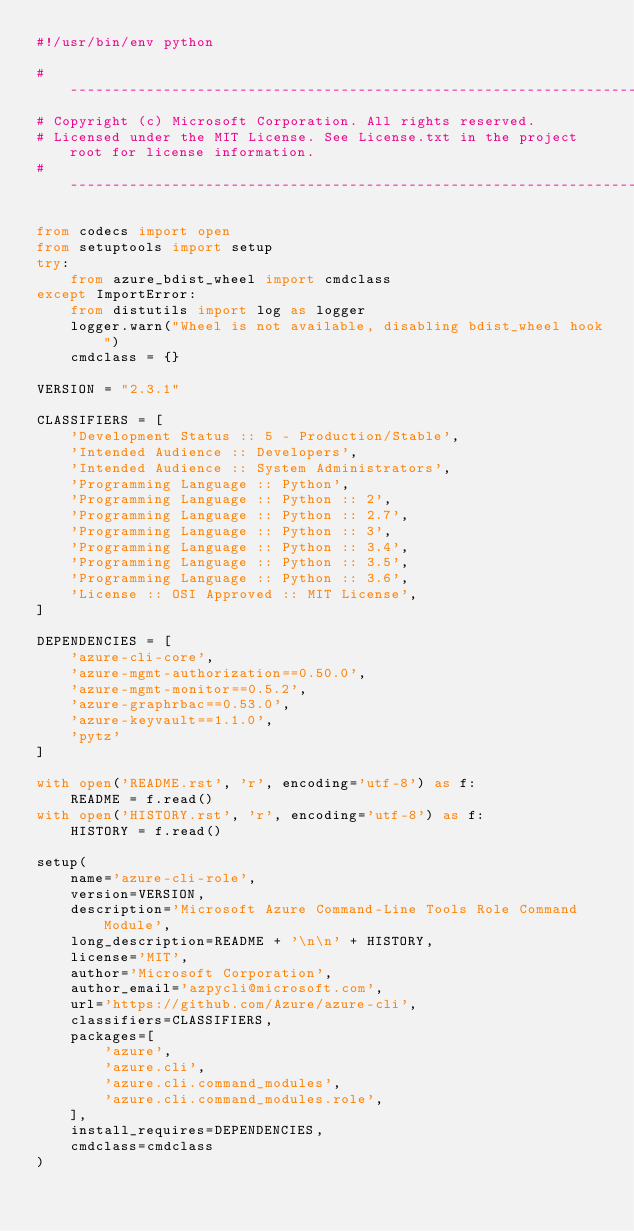Convert code to text. <code><loc_0><loc_0><loc_500><loc_500><_Python_>#!/usr/bin/env python

# --------------------------------------------------------------------------------------------
# Copyright (c) Microsoft Corporation. All rights reserved.
# Licensed under the MIT License. See License.txt in the project root for license information.
# --------------------------------------------------------------------------------------------

from codecs import open
from setuptools import setup
try:
    from azure_bdist_wheel import cmdclass
except ImportError:
    from distutils import log as logger
    logger.warn("Wheel is not available, disabling bdist_wheel hook")
    cmdclass = {}

VERSION = "2.3.1"

CLASSIFIERS = [
    'Development Status :: 5 - Production/Stable',
    'Intended Audience :: Developers',
    'Intended Audience :: System Administrators',
    'Programming Language :: Python',
    'Programming Language :: Python :: 2',
    'Programming Language :: Python :: 2.7',
    'Programming Language :: Python :: 3',
    'Programming Language :: Python :: 3.4',
    'Programming Language :: Python :: 3.5',
    'Programming Language :: Python :: 3.6',
    'License :: OSI Approved :: MIT License',
]

DEPENDENCIES = [
    'azure-cli-core',
    'azure-mgmt-authorization==0.50.0',
    'azure-mgmt-monitor==0.5.2',
    'azure-graphrbac==0.53.0',
    'azure-keyvault==1.1.0',
    'pytz'
]

with open('README.rst', 'r', encoding='utf-8') as f:
    README = f.read()
with open('HISTORY.rst', 'r', encoding='utf-8') as f:
    HISTORY = f.read()

setup(
    name='azure-cli-role',
    version=VERSION,
    description='Microsoft Azure Command-Line Tools Role Command Module',
    long_description=README + '\n\n' + HISTORY,
    license='MIT',
    author='Microsoft Corporation',
    author_email='azpycli@microsoft.com',
    url='https://github.com/Azure/azure-cli',
    classifiers=CLASSIFIERS,
    packages=[
        'azure',
        'azure.cli',
        'azure.cli.command_modules',
        'azure.cli.command_modules.role',
    ],
    install_requires=DEPENDENCIES,
    cmdclass=cmdclass
)
</code> 